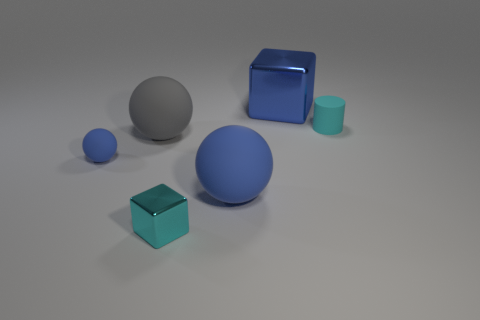Is there a tiny matte thing that has the same color as the small block?
Your response must be concise. Yes. Does the cyan thing left of the blue shiny block have the same size as the big blue cube?
Your answer should be compact. No. Are there fewer small rubber objects than tiny metal things?
Provide a succinct answer. No. Are there any tiny spheres that have the same material as the tiny cylinder?
Give a very brief answer. Yes. What shape is the big blue object left of the large metal cube?
Give a very brief answer. Sphere. There is a cube behind the tiny metallic block; does it have the same color as the small rubber sphere?
Your answer should be compact. Yes. Are there fewer gray matte balls that are in front of the gray object than blue blocks?
Your answer should be very brief. Yes. What is the color of the small thing that is the same material as the tiny ball?
Your answer should be compact. Cyan. How big is the sphere on the right side of the gray matte thing?
Offer a terse response. Large. Are the tiny cylinder and the gray sphere made of the same material?
Give a very brief answer. Yes. 